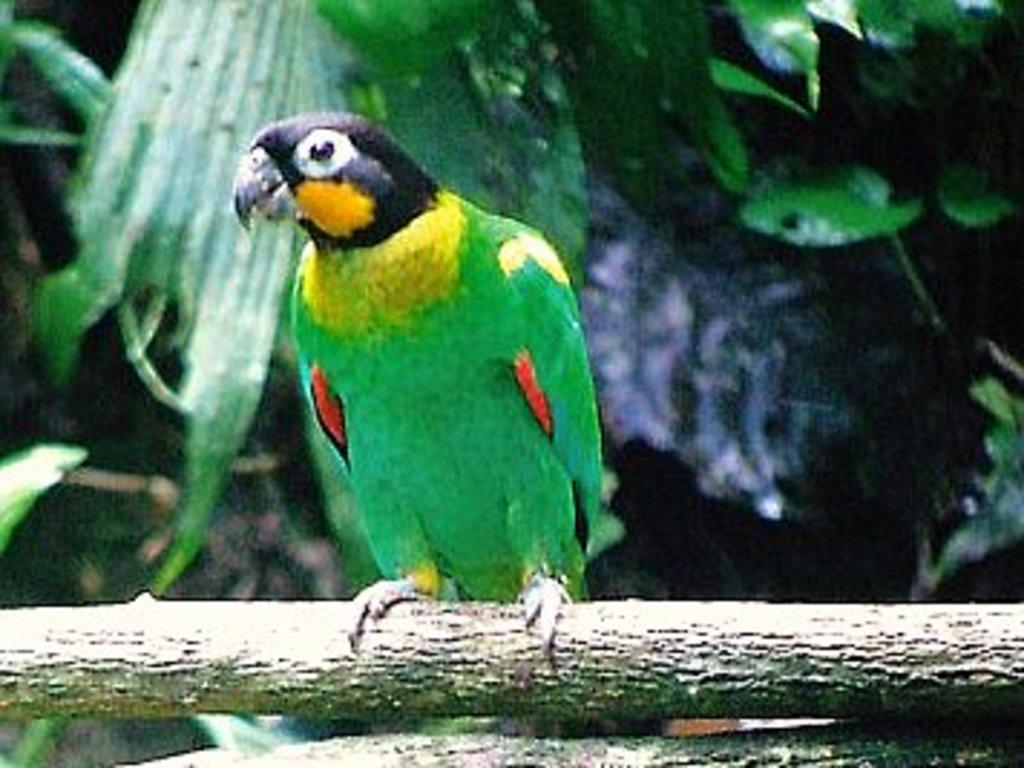What type of animal is in the image? There is a parrot in the image. Where is the parrot located? The parrot is on a branch. What can be seen in the background of the image? There are green leaves in the background of the image. What type of pot is the parrot using to whistle in the image? There is no pot or whistling activity present in the image; it features a parrot on a branch with green leaves in the background. 